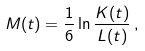<formula> <loc_0><loc_0><loc_500><loc_500>M ( t ) = \frac { 1 } { 6 } \ln \frac { K ( t ) } { L ( t ) } \, ,</formula> 